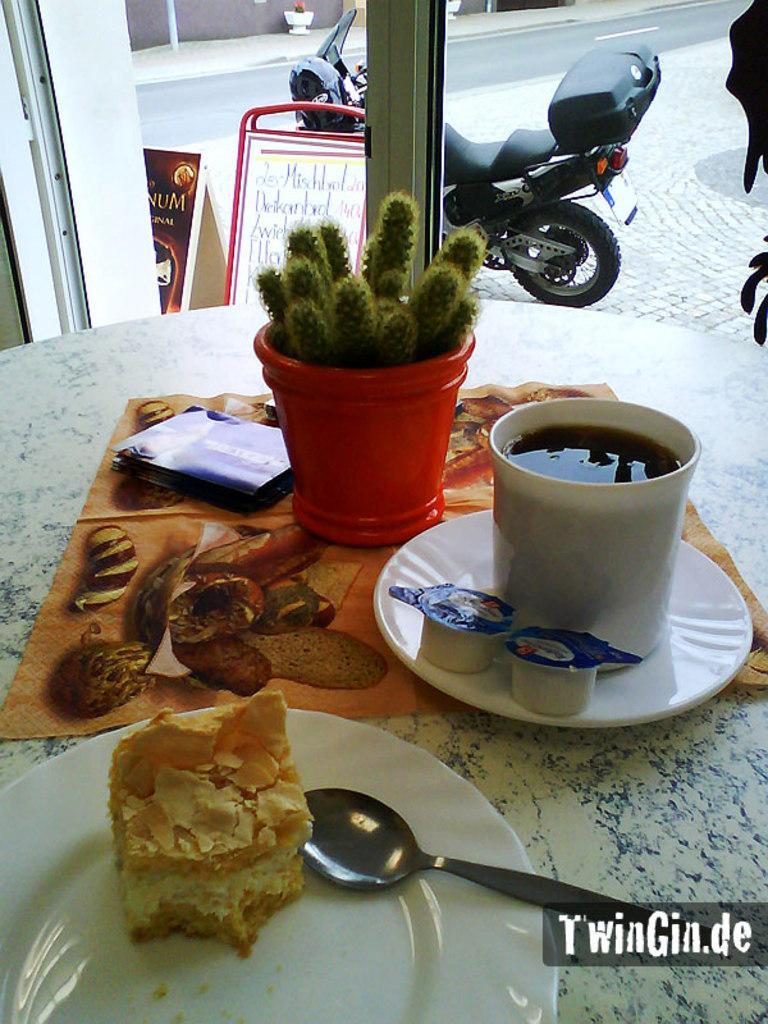Please provide a concise description of this image. In this image we can see a serving table on which we can see a serving plate with dessert in it, cutlery, sauce dips, beverage mug, house plant and a polythene cover. In the background we can see a motor vehicle on the road and advertisement boards. 